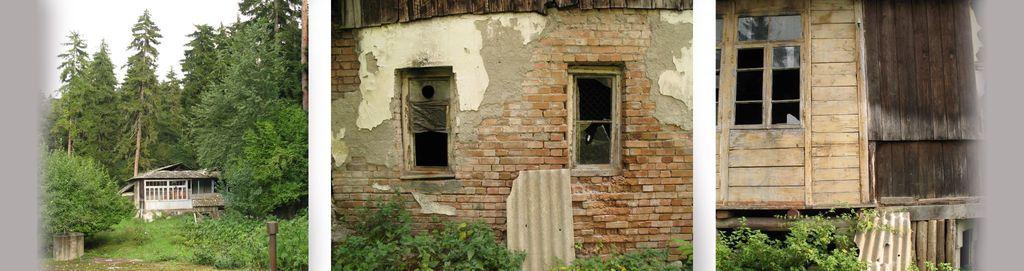Describe this image in one or two sentences. In this image we can see collage images of houses, trees and plants. 